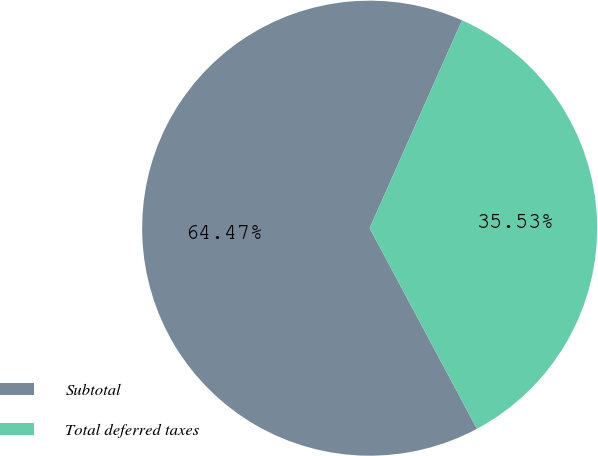<chart> <loc_0><loc_0><loc_500><loc_500><pie_chart><fcel>Subtotal<fcel>Total deferred taxes<nl><fcel>64.47%<fcel>35.53%<nl></chart> 